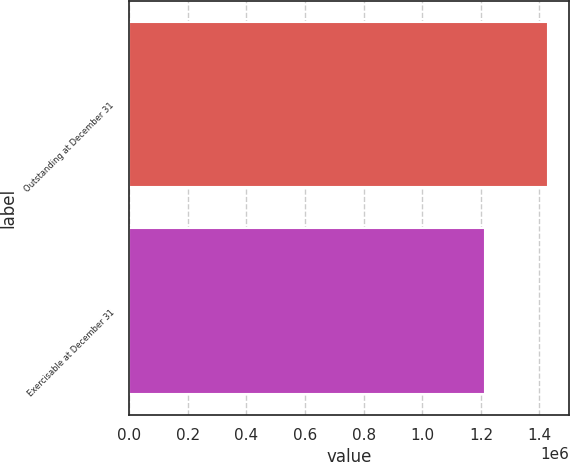<chart> <loc_0><loc_0><loc_500><loc_500><bar_chart><fcel>Outstanding at December 31<fcel>Exercisable at December 31<nl><fcel>1.42982e+06<fcel>1.2141e+06<nl></chart> 